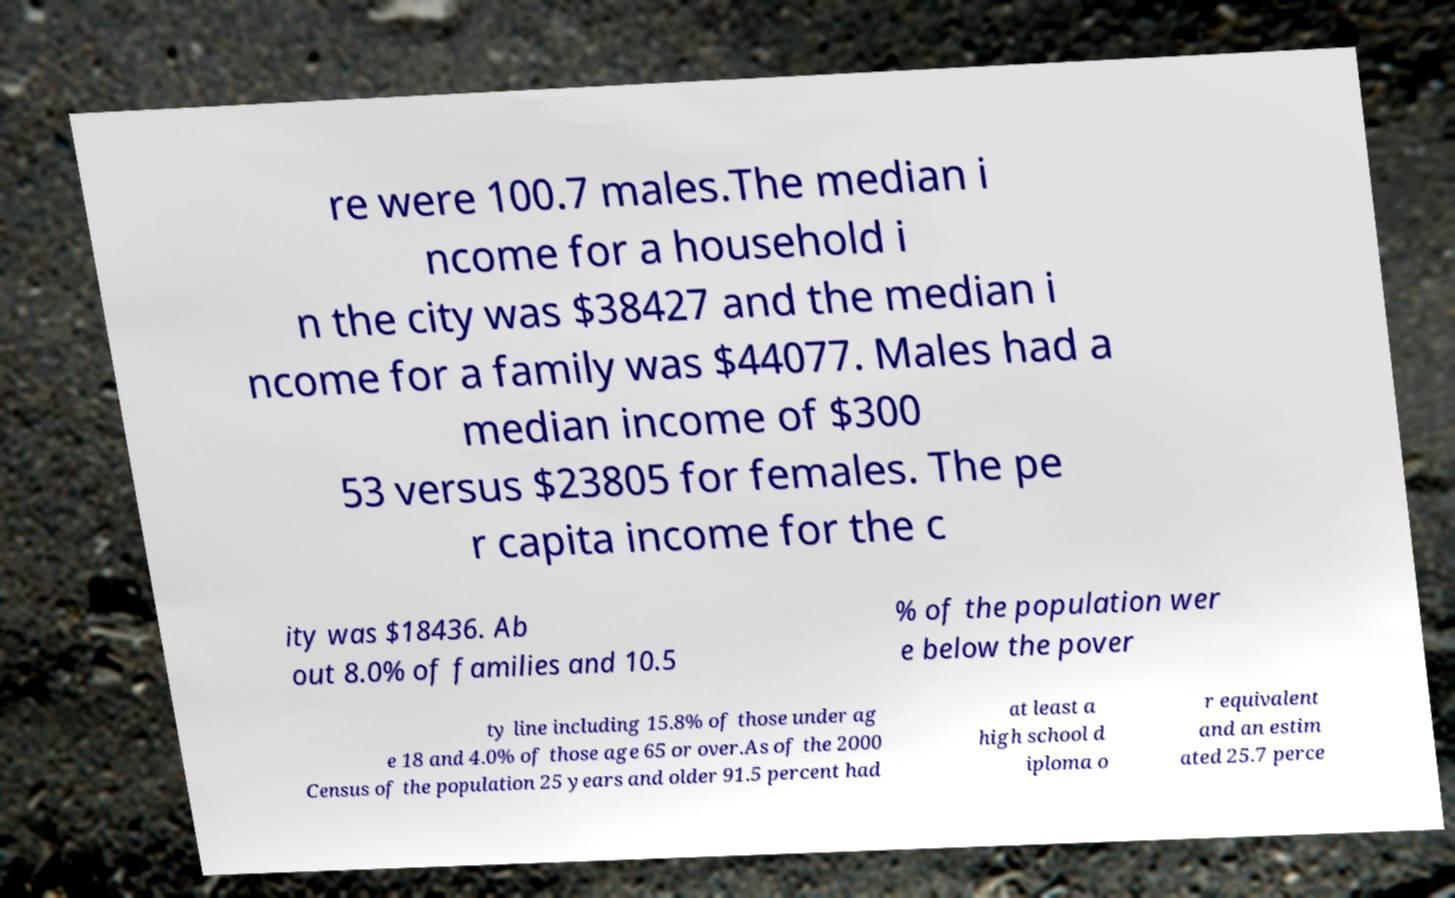What messages or text are displayed in this image? I need them in a readable, typed format. re were 100.7 males.The median i ncome for a household i n the city was $38427 and the median i ncome for a family was $44077. Males had a median income of $300 53 versus $23805 for females. The pe r capita income for the c ity was $18436. Ab out 8.0% of families and 10.5 % of the population wer e below the pover ty line including 15.8% of those under ag e 18 and 4.0% of those age 65 or over.As of the 2000 Census of the population 25 years and older 91.5 percent had at least a high school d iploma o r equivalent and an estim ated 25.7 perce 